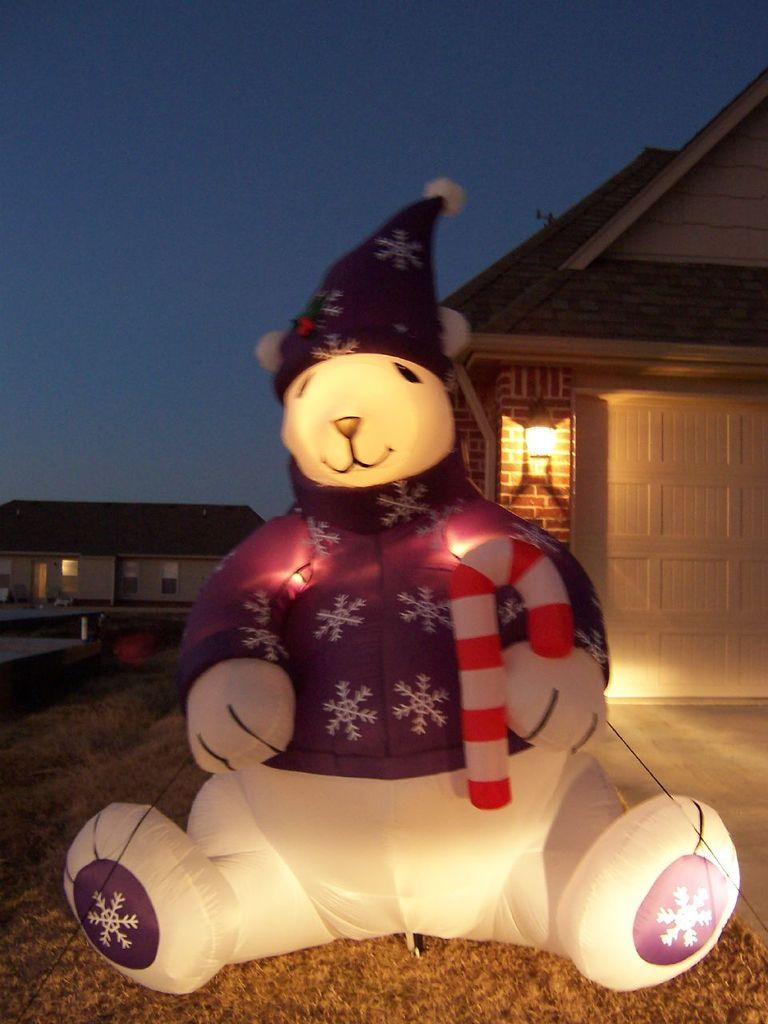What type of object is in the image? There is an inflatable toy in the image. What can be seen in the background of the image? There are lights and houses visible in the background of the image. What type of button can be seen on the inflatable toy in the image? A: There is no button visible on the inflatable toy in the image. What territory does the chicken in the image belong to? There is no chicken present in the image. 